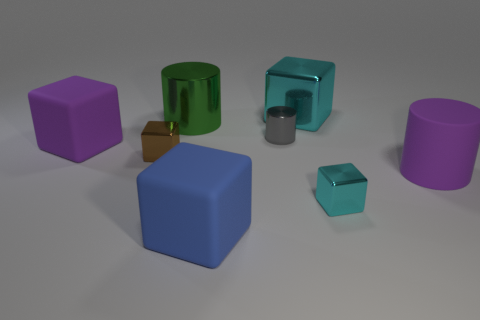Subtract all brown blocks. How many blocks are left? 4 Subtract all large blue matte blocks. How many blocks are left? 4 Subtract 1 cylinders. How many cylinders are left? 2 Add 1 large purple blocks. How many objects exist? 9 Subtract all green cubes. Subtract all gray cylinders. How many cubes are left? 5 Subtract all cylinders. How many objects are left? 5 Add 8 big metallic cubes. How many big metallic cubes exist? 9 Subtract 0 yellow cylinders. How many objects are left? 8 Subtract all green cylinders. Subtract all purple shiny spheres. How many objects are left? 7 Add 1 tiny brown metal objects. How many tiny brown metal objects are left? 2 